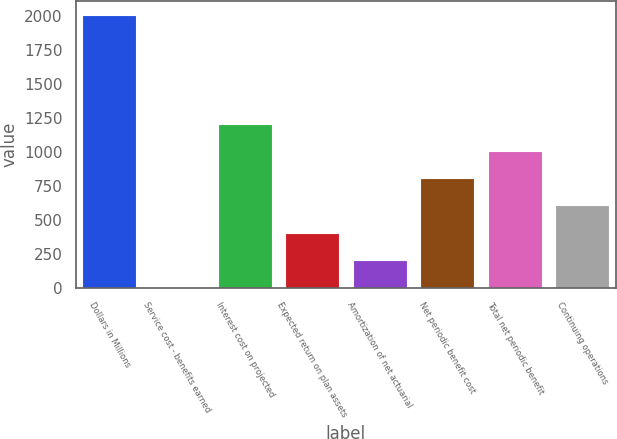Convert chart to OTSL. <chart><loc_0><loc_0><loc_500><loc_500><bar_chart><fcel>Dollars in Millions<fcel>Service cost - benefits earned<fcel>Interest cost on projected<fcel>Expected return on plan assets<fcel>Amortization of net actuarial<fcel>Net periodic benefit cost<fcel>Total net periodic benefit<fcel>Continuing operations<nl><fcel>2009<fcel>6<fcel>1207.8<fcel>406.6<fcel>206.3<fcel>807.2<fcel>1007.5<fcel>606.9<nl></chart> 